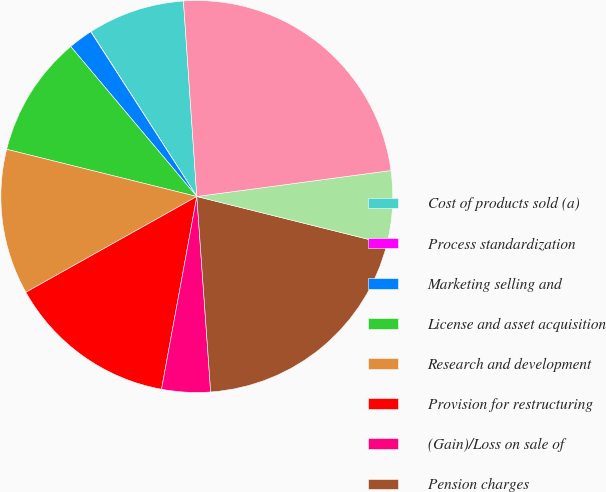Convert chart to OTSL. <chart><loc_0><loc_0><loc_500><loc_500><pie_chart><fcel>Cost of products sold (a)<fcel>Process standardization<fcel>Marketing selling and<fcel>License and asset acquisition<fcel>Research and development<fcel>Provision for restructuring<fcel>(Gain)/Loss on sale of<fcel>Pension charges<fcel>Litigation and other<fcel>Other (income)/expense<nl><fcel>8.0%<fcel>0.02%<fcel>2.02%<fcel>10.0%<fcel>12.0%<fcel>13.99%<fcel>4.01%<fcel>19.98%<fcel>6.01%<fcel>23.97%<nl></chart> 